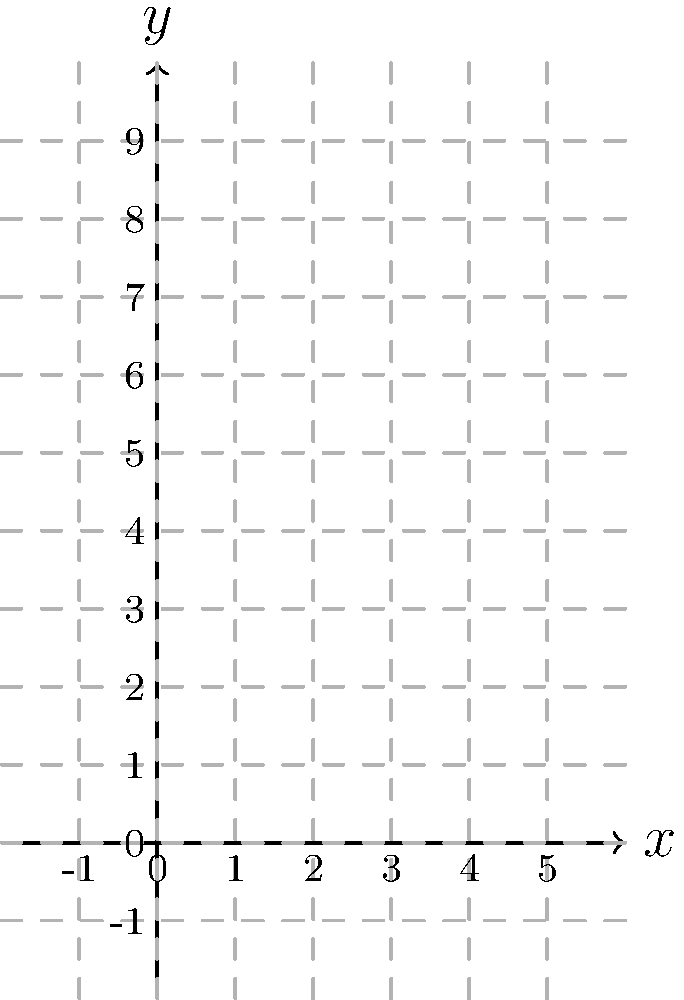As a software product owner, you're developing a feature that requires precise curve fitting for data visualization. Given a parabola with vertex $V(2,1)$ and a point $P(4,5)$ on the curve, determine the equation of the parabola in the form $y = a(x-h)^2 + k$, where $(h,k)$ is the vertex. How would you represent this equation to ensure accurate data representation in your software? To determine the equation of the parabola, we'll follow these steps:

1) The general form of a parabola with vertex $(h,k)$ is:

   $y = a(x-h)^2 + k$

2) We're given the vertex $V(2,1)$, so $h=2$ and $k=1$. Substituting these:

   $y = a(x-2)^2 + 1$

3) To find $a$, we'll use the point $P(4,5)$ that lies on the parabola:

   $5 = a(4-2)^2 + 1$

4) Simplify:

   $5 = a(2)^2 + 1$
   $5 = 4a + 1$

5) Solve for $a$:

   $4 = 4a$
   $a = 1$

6) Substitute $a=1$ into the equation from step 2:

   $y = 1(x-2)^2 + 1$

Therefore, the equation of the parabola is $y = (x-2)^2 + 1$.
Answer: $y = (x-2)^2 + 1$ 